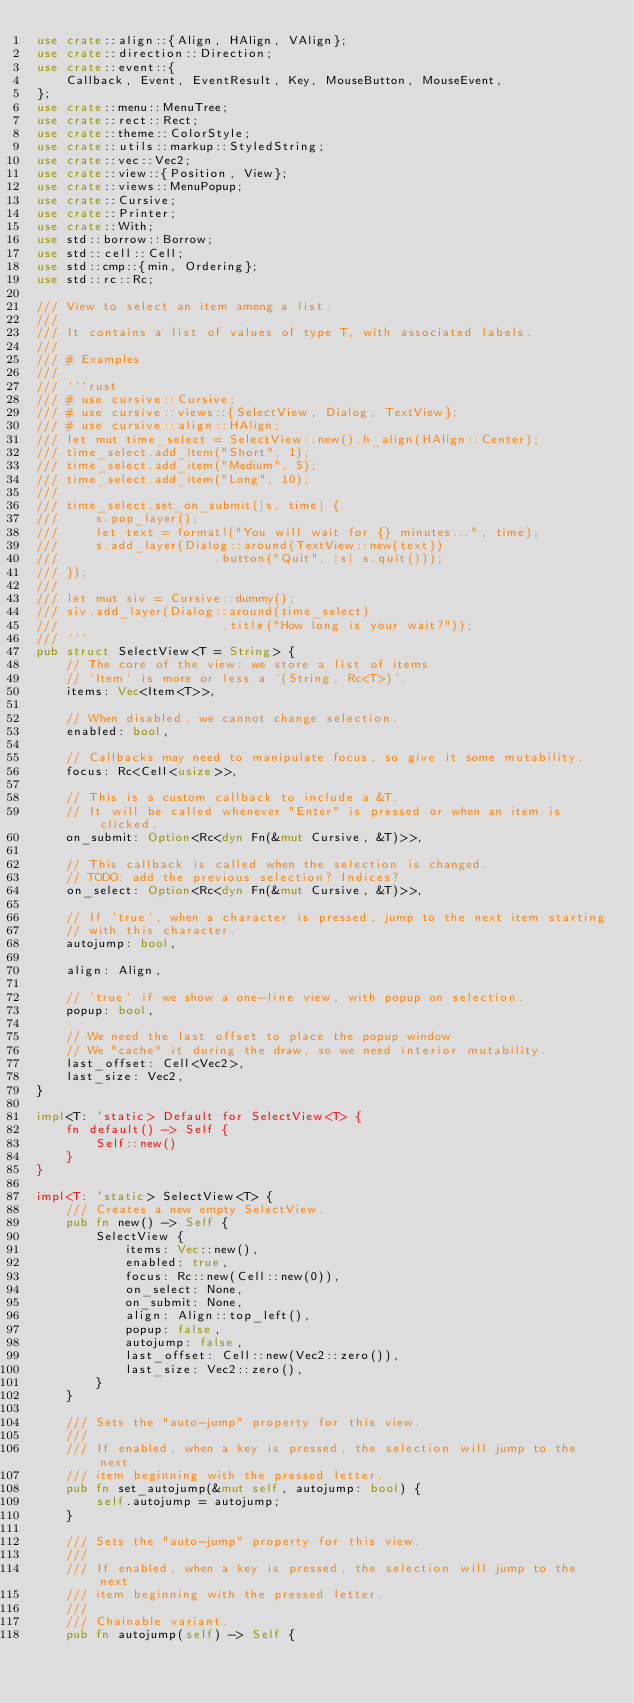<code> <loc_0><loc_0><loc_500><loc_500><_Rust_>use crate::align::{Align, HAlign, VAlign};
use crate::direction::Direction;
use crate::event::{
    Callback, Event, EventResult, Key, MouseButton, MouseEvent,
};
use crate::menu::MenuTree;
use crate::rect::Rect;
use crate::theme::ColorStyle;
use crate::utils::markup::StyledString;
use crate::vec::Vec2;
use crate::view::{Position, View};
use crate::views::MenuPopup;
use crate::Cursive;
use crate::Printer;
use crate::With;
use std::borrow::Borrow;
use std::cell::Cell;
use std::cmp::{min, Ordering};
use std::rc::Rc;

/// View to select an item among a list.
///
/// It contains a list of values of type T, with associated labels.
///
/// # Examples
///
/// ```rust
/// # use cursive::Cursive;
/// # use cursive::views::{SelectView, Dialog, TextView};
/// # use cursive::align::HAlign;
/// let mut time_select = SelectView::new().h_align(HAlign::Center);
/// time_select.add_item("Short", 1);
/// time_select.add_item("Medium", 5);
/// time_select.add_item("Long", 10);
///
/// time_select.set_on_submit(|s, time| {
///     s.pop_layer();
///     let text = format!("You will wait for {} minutes...", time);
///     s.add_layer(Dialog::around(TextView::new(text))
///                     .button("Quit", |s| s.quit()));
/// });
///
/// let mut siv = Cursive::dummy();
/// siv.add_layer(Dialog::around(time_select)
///                      .title("How long is your wait?"));
/// ```
pub struct SelectView<T = String> {
    // The core of the view: we store a list of items
    // `Item` is more or less a `(String, Rc<T>)`.
    items: Vec<Item<T>>,

    // When disabled, we cannot change selection.
    enabled: bool,

    // Callbacks may need to manipulate focus, so give it some mutability.
    focus: Rc<Cell<usize>>,

    // This is a custom callback to include a &T.
    // It will be called whenever "Enter" is pressed or when an item is clicked.
    on_submit: Option<Rc<dyn Fn(&mut Cursive, &T)>>,

    // This callback is called when the selection is changed.
    // TODO: add the previous selection? Indices?
    on_select: Option<Rc<dyn Fn(&mut Cursive, &T)>>,

    // If `true`, when a character is pressed, jump to the next item starting
    // with this character.
    autojump: bool,

    align: Align,

    // `true` if we show a one-line view, with popup on selection.
    popup: bool,

    // We need the last offset to place the popup window
    // We "cache" it during the draw, so we need interior mutability.
    last_offset: Cell<Vec2>,
    last_size: Vec2,
}

impl<T: 'static> Default for SelectView<T> {
    fn default() -> Self {
        Self::new()
    }
}

impl<T: 'static> SelectView<T> {
    /// Creates a new empty SelectView.
    pub fn new() -> Self {
        SelectView {
            items: Vec::new(),
            enabled: true,
            focus: Rc::new(Cell::new(0)),
            on_select: None,
            on_submit: None,
            align: Align::top_left(),
            popup: false,
            autojump: false,
            last_offset: Cell::new(Vec2::zero()),
            last_size: Vec2::zero(),
        }
    }

    /// Sets the "auto-jump" property for this view.
    ///
    /// If enabled, when a key is pressed, the selection will jump to the next
    /// item beginning with the pressed letter.
    pub fn set_autojump(&mut self, autojump: bool) {
        self.autojump = autojump;
    }

    /// Sets the "auto-jump" property for this view.
    ///
    /// If enabled, when a key is pressed, the selection will jump to the next
    /// item beginning with the pressed letter.
    ///
    /// Chainable variant.
    pub fn autojump(self) -> Self {</code> 